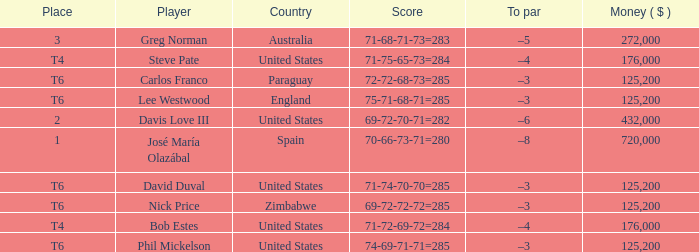Which Score has a Place of t6, and a Country of paraguay? 72-72-68-73=285. 